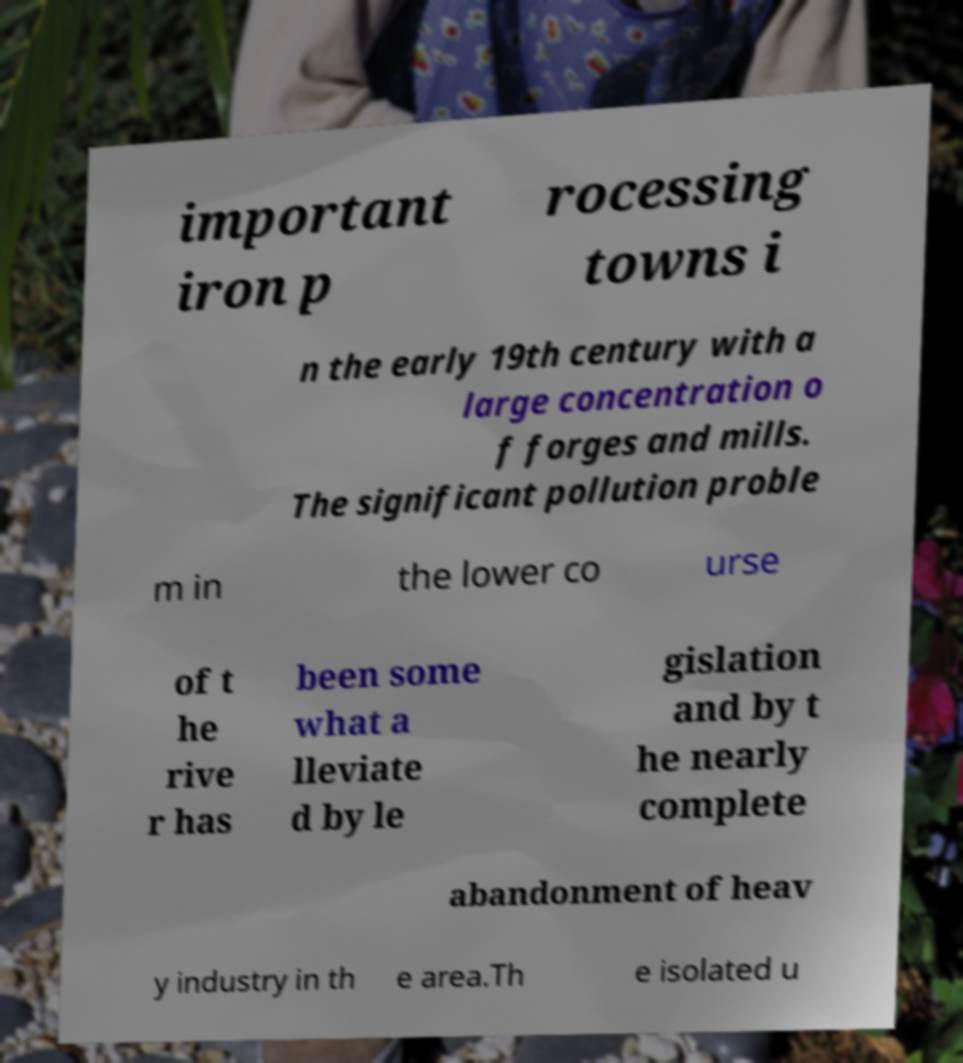Could you extract and type out the text from this image? important iron p rocessing towns i n the early 19th century with a large concentration o f forges and mills. The significant pollution proble m in the lower co urse of t he rive r has been some what a lleviate d by le gislation and by t he nearly complete abandonment of heav y industry in th e area.Th e isolated u 